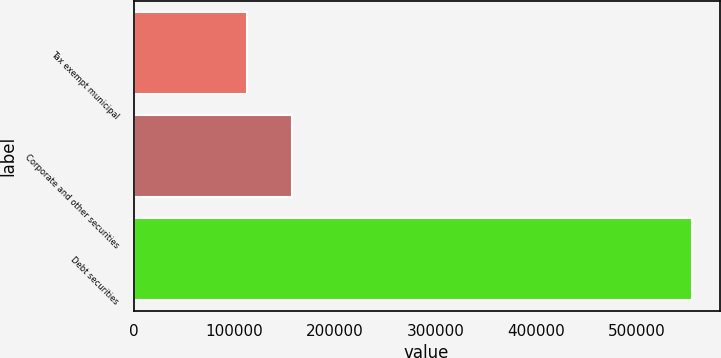<chart> <loc_0><loc_0><loc_500><loc_500><bar_chart><fcel>Tax exempt municipal<fcel>Corporate and other securities<fcel>Debt securities<nl><fcel>112684<fcel>156836<fcel>554208<nl></chart> 